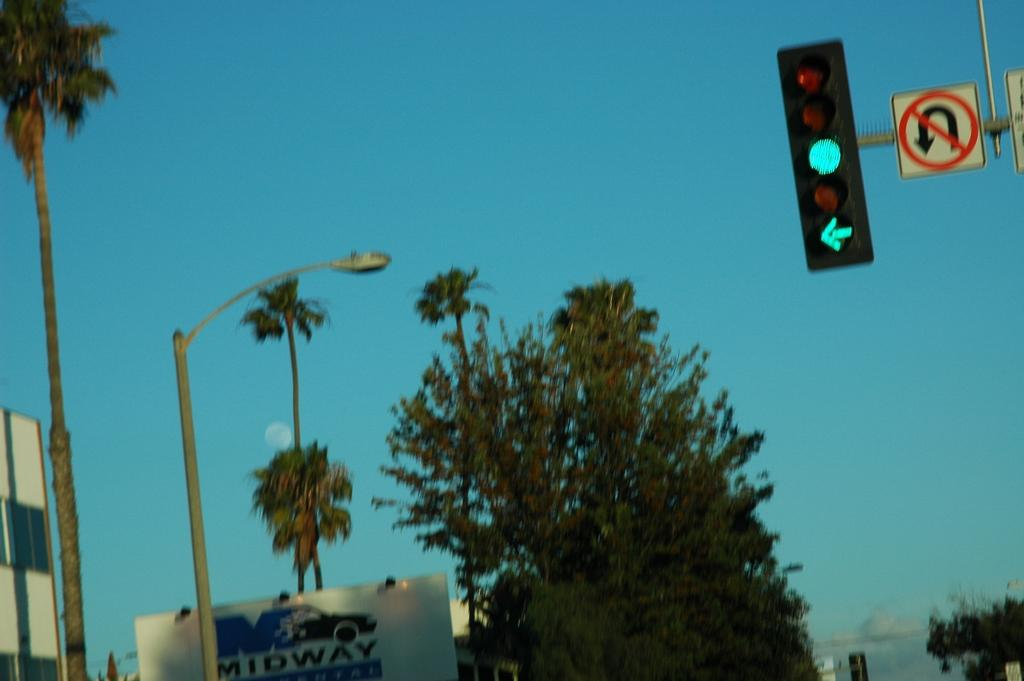<image>
Describe the image concisely. Midway sign that shows also a traffic light that is green and pointing left with a No U Turn sign. 